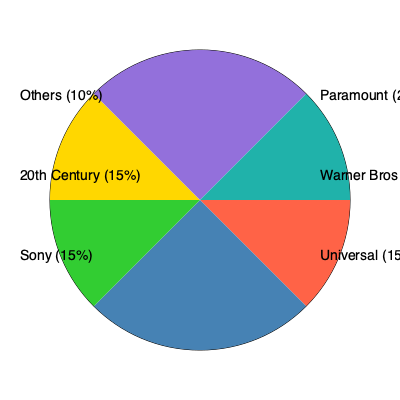Based on the pie chart showing market share of film studios producing detective movies, which two studios combined have a market share equal to Paramount's, and what percentage of the market do they control together? To solve this question, let's follow these steps:

1. Identify Paramount's market share:
   Paramount has 25% of the market share.

2. Find two studios that, when combined, equal 25%:
   Looking at the chart, we can see that Warner Bros. has 20% and Universal has 15%.
   
3. Calculate the sum of Warner Bros. and Universal's market shares:
   $20\% + 15\% = 35\%$

4. Compare the result to Paramount's share:
   $35\% > 25\%$, so this combination exceeds Paramount's share.

5. Look for another combination:
   Universal and Sony both have 15% each.
   $15\% + 15\% = 30\%$

6. Compare this new result to Paramount's share:
   $30\% > 25\%$, so this combination also exceeds Paramount's share.

7. Try one more combination:
   Universal and 20th Century both have 15% each.
   $15\% + 15\% = 30\%$

8. This combination also exceeds Paramount's share.

Therefore, there is no combination of two studios that exactly matches Paramount's 25% market share. The closest combination is any two studios with 15% each, totaling 30% of the market.
Answer: Universal and Sony (or 20th Century), 30% 